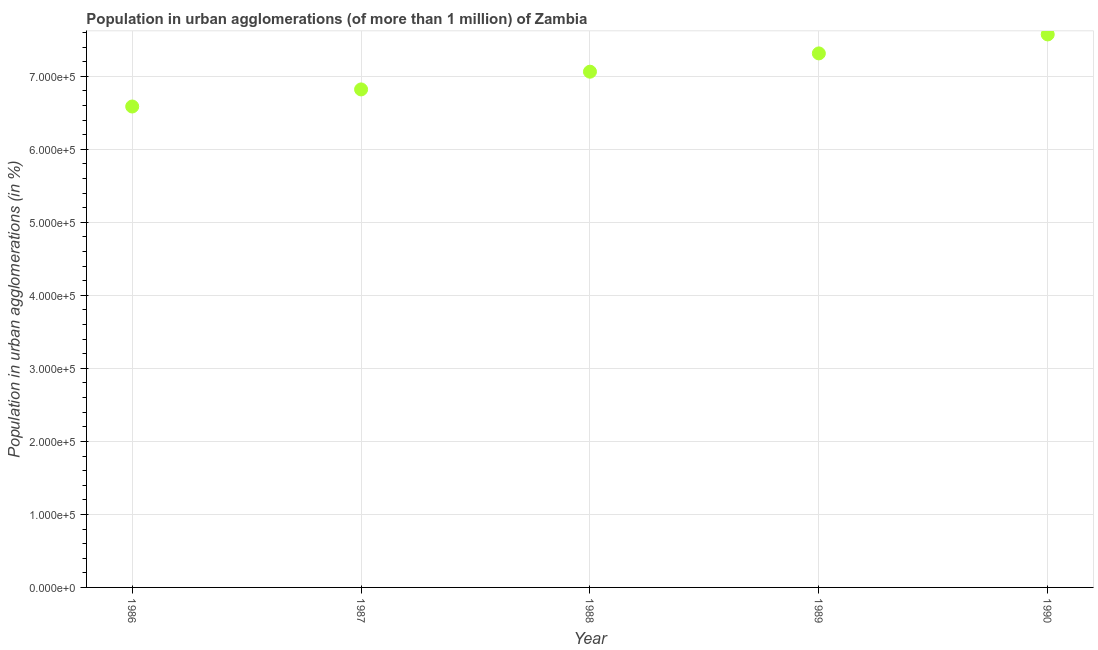What is the population in urban agglomerations in 1990?
Your answer should be very brief. 7.57e+05. Across all years, what is the maximum population in urban agglomerations?
Give a very brief answer. 7.57e+05. Across all years, what is the minimum population in urban agglomerations?
Offer a very short reply. 6.59e+05. In which year was the population in urban agglomerations maximum?
Provide a short and direct response. 1990. In which year was the population in urban agglomerations minimum?
Your response must be concise. 1986. What is the sum of the population in urban agglomerations?
Make the answer very short. 3.54e+06. What is the difference between the population in urban agglomerations in 1987 and 1989?
Provide a short and direct response. -4.93e+04. What is the average population in urban agglomerations per year?
Provide a succinct answer. 7.07e+05. What is the median population in urban agglomerations?
Your answer should be compact. 7.06e+05. What is the ratio of the population in urban agglomerations in 1988 to that in 1990?
Provide a short and direct response. 0.93. What is the difference between the highest and the second highest population in urban agglomerations?
Provide a short and direct response. 2.60e+04. Is the sum of the population in urban agglomerations in 1987 and 1988 greater than the maximum population in urban agglomerations across all years?
Your response must be concise. Yes. What is the difference between the highest and the lowest population in urban agglomerations?
Your response must be concise. 9.87e+04. In how many years, is the population in urban agglomerations greater than the average population in urban agglomerations taken over all years?
Provide a succinct answer. 2. Does the population in urban agglomerations monotonically increase over the years?
Provide a short and direct response. Yes. What is the difference between two consecutive major ticks on the Y-axis?
Keep it short and to the point. 1.00e+05. Does the graph contain grids?
Ensure brevity in your answer.  Yes. What is the title of the graph?
Provide a short and direct response. Population in urban agglomerations (of more than 1 million) of Zambia. What is the label or title of the Y-axis?
Give a very brief answer. Population in urban agglomerations (in %). What is the Population in urban agglomerations (in %) in 1986?
Make the answer very short. 6.59e+05. What is the Population in urban agglomerations (in %) in 1987?
Provide a short and direct response. 6.82e+05. What is the Population in urban agglomerations (in %) in 1988?
Make the answer very short. 7.06e+05. What is the Population in urban agglomerations (in %) in 1989?
Keep it short and to the point. 7.31e+05. What is the Population in urban agglomerations (in %) in 1990?
Keep it short and to the point. 7.57e+05. What is the difference between the Population in urban agglomerations (in %) in 1986 and 1987?
Keep it short and to the point. -2.34e+04. What is the difference between the Population in urban agglomerations (in %) in 1986 and 1988?
Your answer should be compact. -4.77e+04. What is the difference between the Population in urban agglomerations (in %) in 1986 and 1989?
Provide a succinct answer. -7.27e+04. What is the difference between the Population in urban agglomerations (in %) in 1986 and 1990?
Give a very brief answer. -9.87e+04. What is the difference between the Population in urban agglomerations (in %) in 1987 and 1988?
Make the answer very short. -2.43e+04. What is the difference between the Population in urban agglomerations (in %) in 1987 and 1989?
Give a very brief answer. -4.93e+04. What is the difference between the Population in urban agglomerations (in %) in 1987 and 1990?
Give a very brief answer. -7.53e+04. What is the difference between the Population in urban agglomerations (in %) in 1988 and 1989?
Make the answer very short. -2.51e+04. What is the difference between the Population in urban agglomerations (in %) in 1988 and 1990?
Your answer should be very brief. -5.10e+04. What is the difference between the Population in urban agglomerations (in %) in 1989 and 1990?
Your response must be concise. -2.60e+04. What is the ratio of the Population in urban agglomerations (in %) in 1986 to that in 1988?
Your answer should be compact. 0.93. What is the ratio of the Population in urban agglomerations (in %) in 1986 to that in 1989?
Provide a succinct answer. 0.9. What is the ratio of the Population in urban agglomerations (in %) in 1986 to that in 1990?
Give a very brief answer. 0.87. What is the ratio of the Population in urban agglomerations (in %) in 1987 to that in 1989?
Ensure brevity in your answer.  0.93. What is the ratio of the Population in urban agglomerations (in %) in 1987 to that in 1990?
Your response must be concise. 0.9. What is the ratio of the Population in urban agglomerations (in %) in 1988 to that in 1989?
Provide a short and direct response. 0.97. What is the ratio of the Population in urban agglomerations (in %) in 1988 to that in 1990?
Offer a very short reply. 0.93. What is the ratio of the Population in urban agglomerations (in %) in 1989 to that in 1990?
Provide a succinct answer. 0.97. 